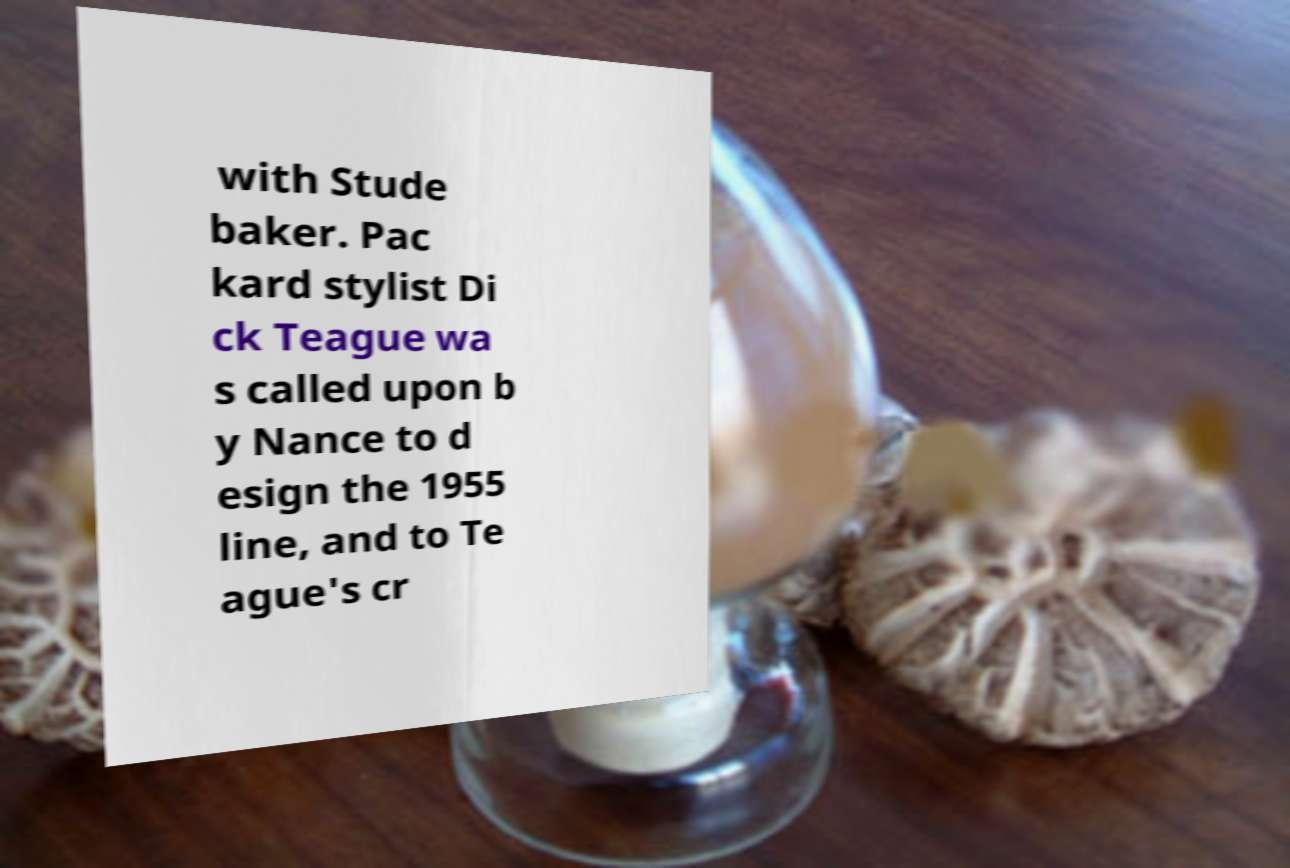I need the written content from this picture converted into text. Can you do that? with Stude baker. Pac kard stylist Di ck Teague wa s called upon b y Nance to d esign the 1955 line, and to Te ague's cr 